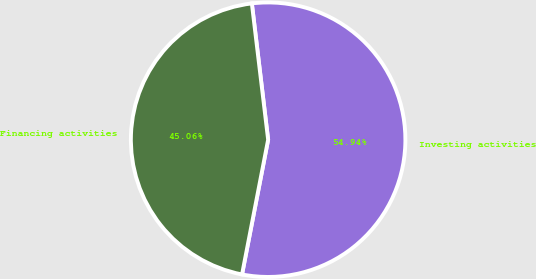Convert chart to OTSL. <chart><loc_0><loc_0><loc_500><loc_500><pie_chart><fcel>Investing activities<fcel>Financing activities<nl><fcel>54.94%<fcel>45.06%<nl></chart> 